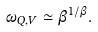Convert formula to latex. <formula><loc_0><loc_0><loc_500><loc_500>\omega _ { Q , V } \simeq \beta ^ { 1 / \beta } .</formula> 